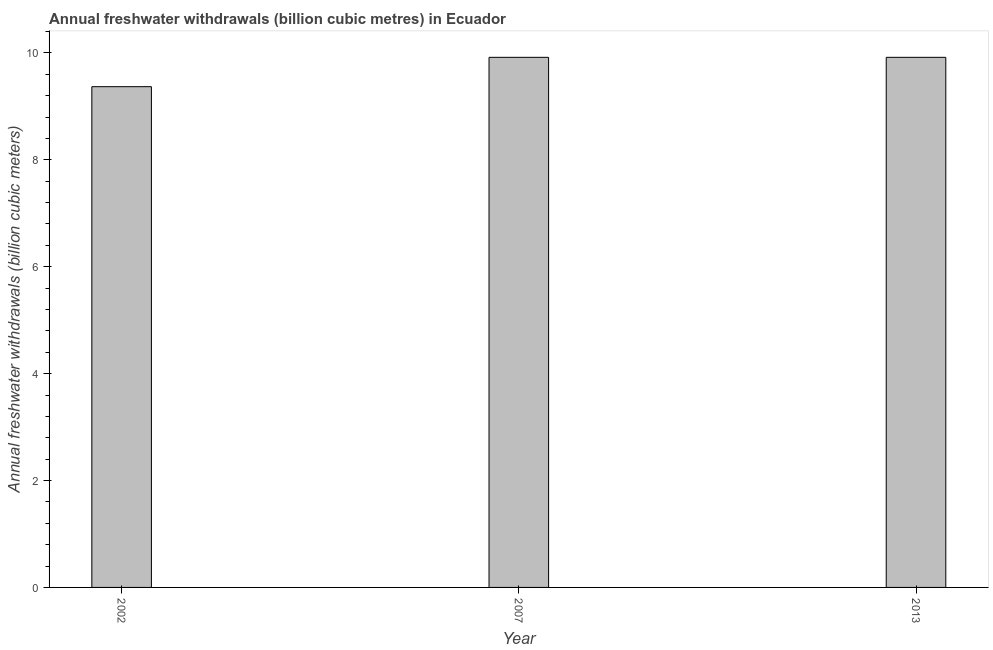Does the graph contain any zero values?
Your answer should be very brief. No. What is the title of the graph?
Ensure brevity in your answer.  Annual freshwater withdrawals (billion cubic metres) in Ecuador. What is the label or title of the X-axis?
Make the answer very short. Year. What is the label or title of the Y-axis?
Your answer should be compact. Annual freshwater withdrawals (billion cubic meters). What is the annual freshwater withdrawals in 2002?
Keep it short and to the point. 9.37. Across all years, what is the maximum annual freshwater withdrawals?
Make the answer very short. 9.92. Across all years, what is the minimum annual freshwater withdrawals?
Your response must be concise. 9.37. In which year was the annual freshwater withdrawals minimum?
Offer a very short reply. 2002. What is the sum of the annual freshwater withdrawals?
Offer a very short reply. 29.2. What is the difference between the annual freshwater withdrawals in 2007 and 2013?
Offer a terse response. 0. What is the average annual freshwater withdrawals per year?
Ensure brevity in your answer.  9.73. What is the median annual freshwater withdrawals?
Your answer should be very brief. 9.92. In how many years, is the annual freshwater withdrawals greater than 6.8 billion cubic meters?
Provide a succinct answer. 3. Do a majority of the years between 2002 and 2013 (inclusive) have annual freshwater withdrawals greater than 5.6 billion cubic meters?
Give a very brief answer. Yes. What is the ratio of the annual freshwater withdrawals in 2002 to that in 2007?
Make the answer very short. 0.94. Is the annual freshwater withdrawals in 2007 less than that in 2013?
Give a very brief answer. No. Is the difference between the annual freshwater withdrawals in 2007 and 2013 greater than the difference between any two years?
Give a very brief answer. No. What is the difference between the highest and the second highest annual freshwater withdrawals?
Ensure brevity in your answer.  0. Is the sum of the annual freshwater withdrawals in 2002 and 2013 greater than the maximum annual freshwater withdrawals across all years?
Your answer should be compact. Yes. What is the difference between the highest and the lowest annual freshwater withdrawals?
Ensure brevity in your answer.  0.55. Are all the bars in the graph horizontal?
Make the answer very short. No. How many years are there in the graph?
Make the answer very short. 3. What is the difference between two consecutive major ticks on the Y-axis?
Your response must be concise. 2. What is the Annual freshwater withdrawals (billion cubic meters) of 2002?
Keep it short and to the point. 9.37. What is the Annual freshwater withdrawals (billion cubic meters) in 2007?
Ensure brevity in your answer.  9.92. What is the Annual freshwater withdrawals (billion cubic meters) of 2013?
Keep it short and to the point. 9.92. What is the difference between the Annual freshwater withdrawals (billion cubic meters) in 2002 and 2007?
Ensure brevity in your answer.  -0.55. What is the difference between the Annual freshwater withdrawals (billion cubic meters) in 2002 and 2013?
Make the answer very short. -0.55. What is the ratio of the Annual freshwater withdrawals (billion cubic meters) in 2002 to that in 2007?
Provide a short and direct response. 0.94. What is the ratio of the Annual freshwater withdrawals (billion cubic meters) in 2002 to that in 2013?
Your answer should be very brief. 0.94. What is the ratio of the Annual freshwater withdrawals (billion cubic meters) in 2007 to that in 2013?
Give a very brief answer. 1. 